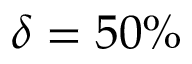Convert formula to latex. <formula><loc_0><loc_0><loc_500><loc_500>\delta = 5 0 \%</formula> 